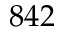Convert formula to latex. <formula><loc_0><loc_0><loc_500><loc_500>8 4 2</formula> 